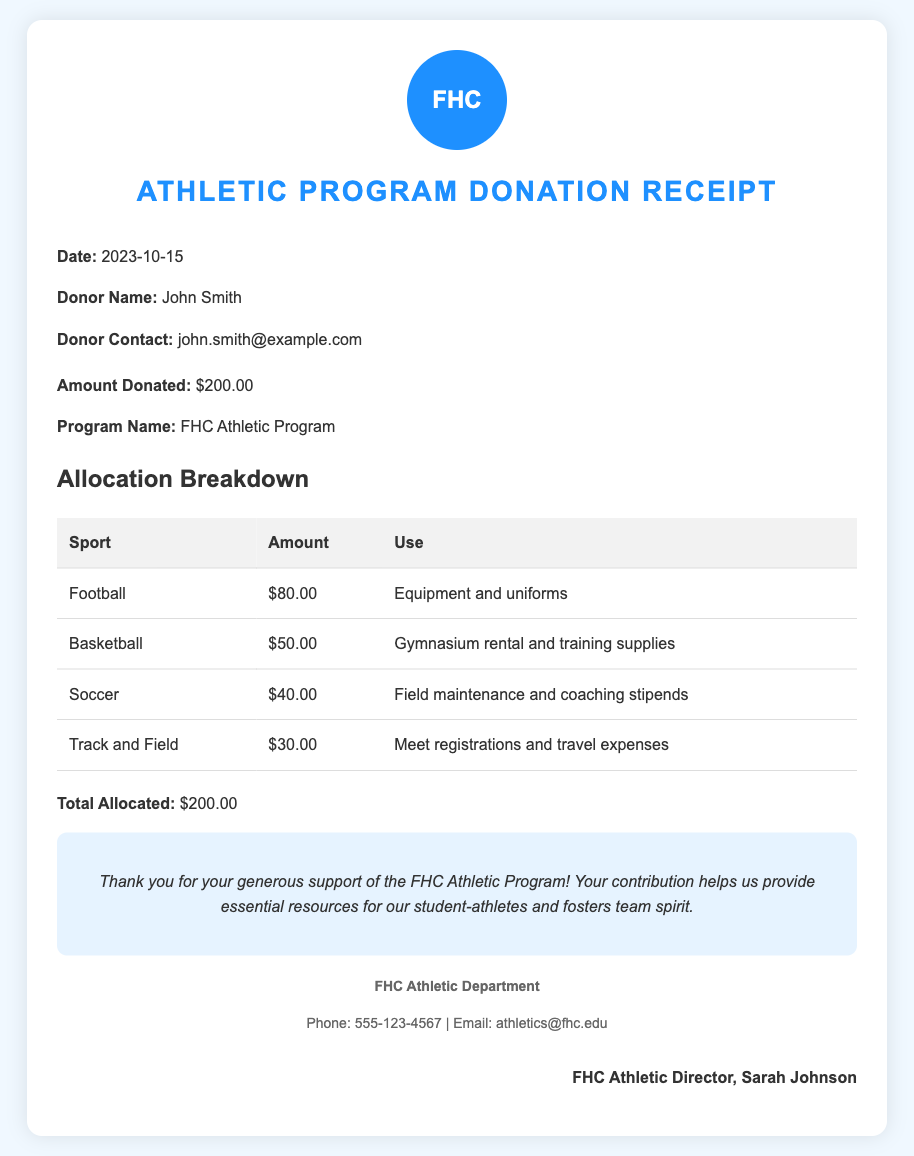What is the date of the donation? The date of the donation is specified in the document, which is 2023-10-15.
Answer: 2023-10-15 Who is the donor? The document names the donor as John Smith.
Answer: John Smith How much was donated? The total donation amount is clearly indicated in the document as $200.00.
Answer: $200.00 What sport received the most funding? The document lists funding for different sports, with Football receiving the highest amount of $80.00.
Answer: Football What is the total allocated amount? The document summarizes the total amount allocated to various sports, which equals $200.00.
Answer: $200.00 What is the purpose of the funds for Soccer? The purpose of the funds allocated for Soccer is included in the document, which states it is for field maintenance and coaching stipends.
Answer: Field maintenance and coaching stipends Who signed the document? The signature section states that it was signed by FHC Athletic Director, Sarah Johnson.
Answer: Sarah Johnson What percentage of the donation goes to Basketball? Basketball received $50.00 out of the total donation of $200.00, which makes it 25%.
Answer: 25% What contact information is provided for the FHC Athletic Department? The document contains contact information, including the phone number and email address of the FHC Athletic Department, which is 555-123-4567 and athletics@fhc.edu.
Answer: 555-123-4567, athletics@fhc.edu 